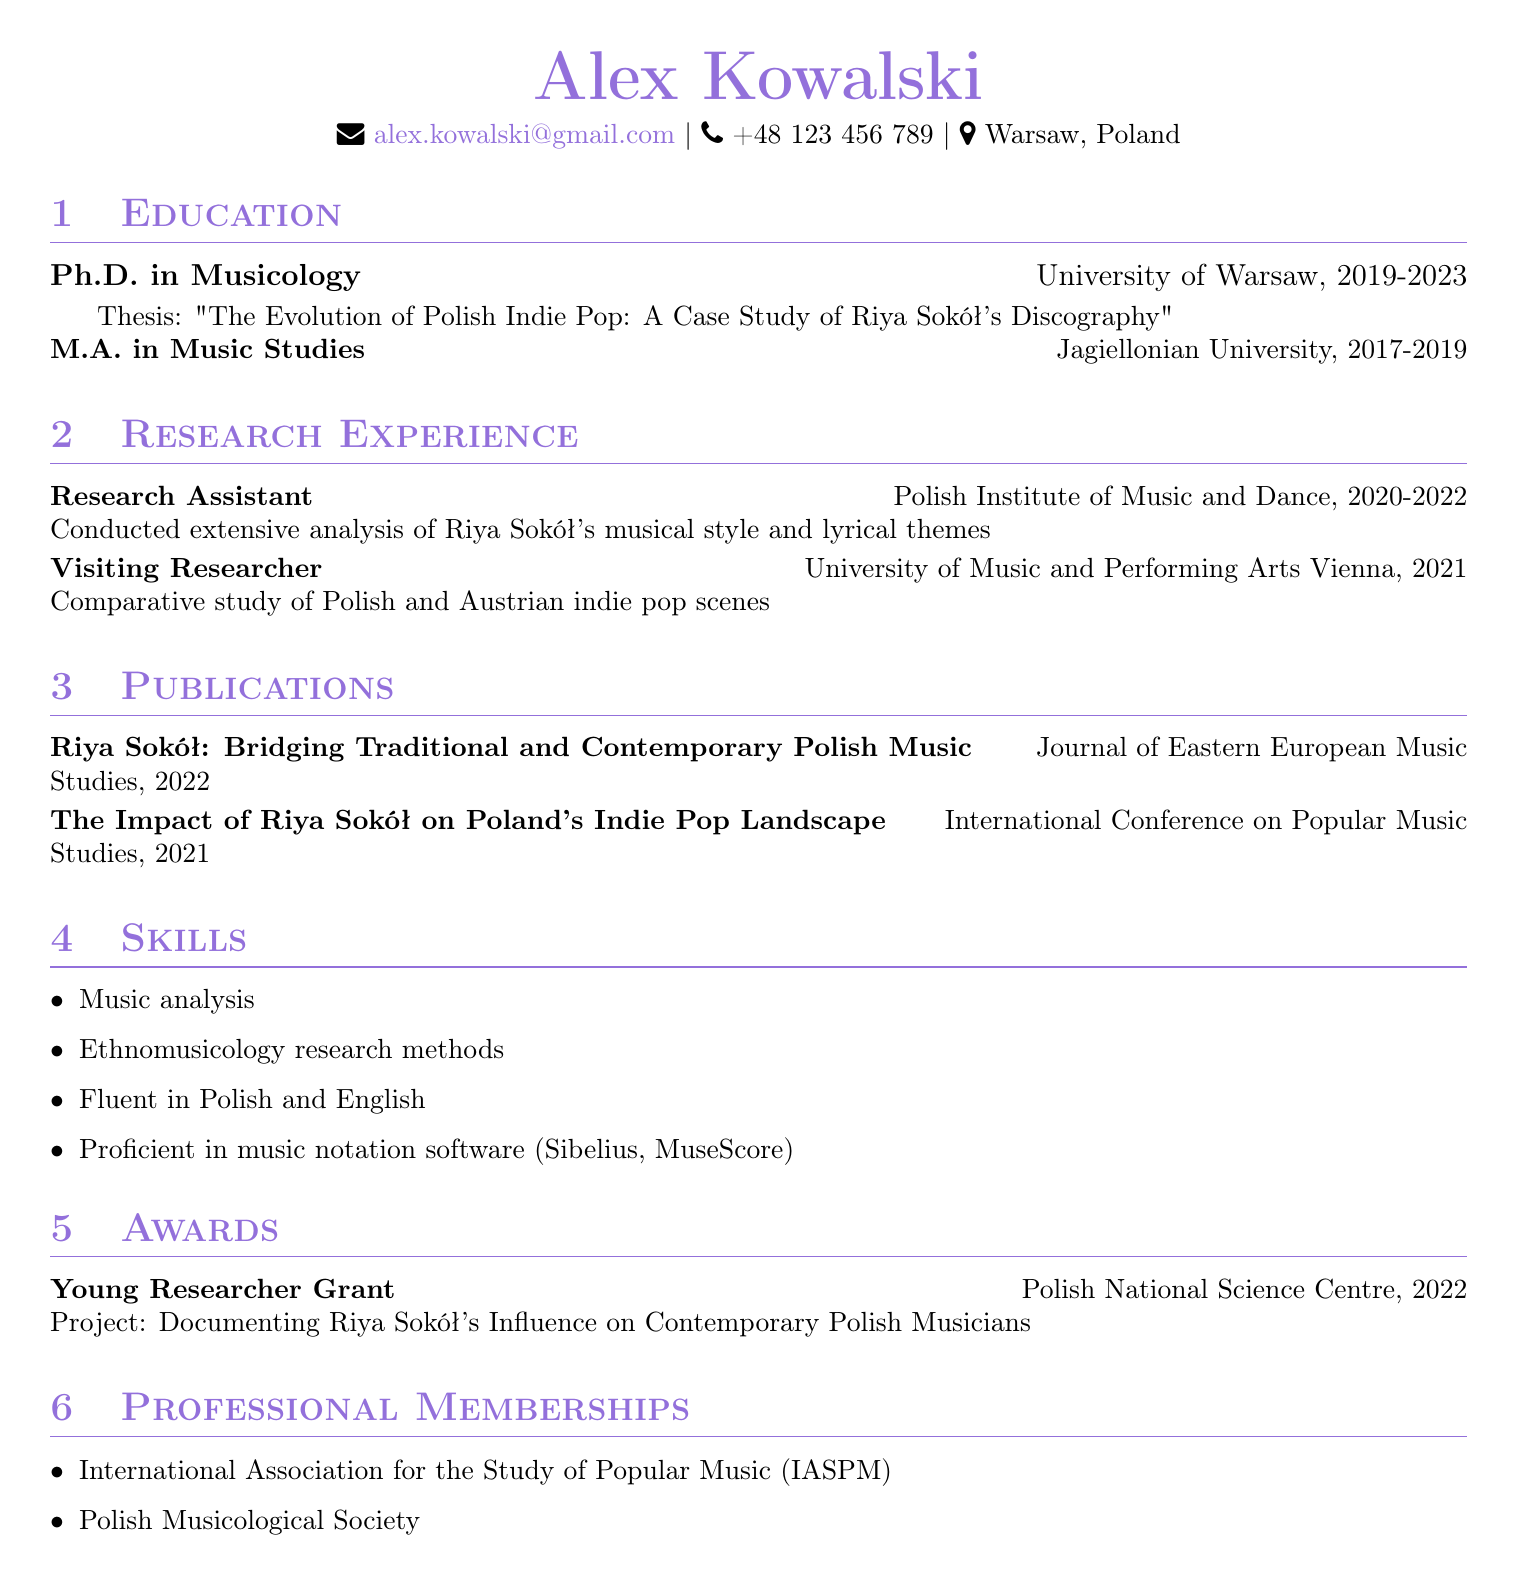what is Alex Kowalski's highest degree? The highest degree listed in the document is the Ph.D. in Musicology from the University of Warsaw.
Answer: Ph.D. in Musicology what is the title of Alex Kowalski's thesis? The document specifies that the thesis is titled "The Evolution of Polish Indie Pop: A Case Study of Riya Sokół's Discography."
Answer: The Evolution of Polish Indie Pop: A Case Study of Riya Sokół's Discography which award did Alex Kowalski receive in 2022? The document mentions that he received the Young Researcher Grant from the Polish National Science Centre in 2022.
Answer: Young Researcher Grant how many years did Alex Kowalski work as a Research Assistant? The document states that he worked as a Research Assistant from 2020 to 2022, which totals two years.
Answer: 2 years what is the focus of the research conducted at the Polish Institute of Music and Dance? According to the document, the research assistant conducted an extensive analysis of Riya Sokół's musical style and lyrical themes.
Answer: Riya Sokół's musical style and lyrical themes what are the languages Alex Kowalski is fluent in? The document indicates that he is fluent in Polish and English.
Answer: Polish and English what is the name of the journal where Alex Kowalski published his work on Riya Sokół? The publication mentioned is found in the Journal of Eastern European Music Studies.
Answer: Journal of Eastern European Music Studies what was the purpose of the visiting research position at the University of Music and Performing Arts Vienna? The document notes that the purpose was a comparative study of Polish and Austrian indie pop scenes.
Answer: Comparative study of Polish and Austrian indie pop scenes which professional memberships does Alex Kowalski hold? The document lists that he is a member of the International Association for the Study of Popular Music (IASPM) and the Polish Musicological Society.
Answer: IASPM, Polish Musicological Society 